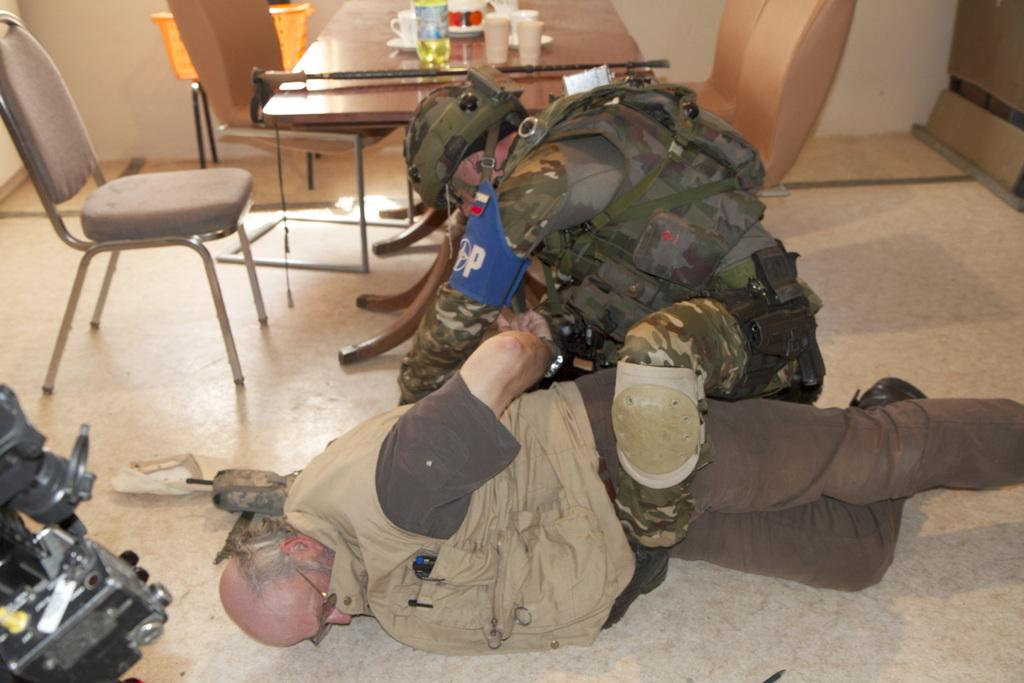How many people are in the image? There are two men in the image. What is the occupation of one of the men? One of the men is an army man. What is the army man doing in the image? The army man is arresting a person. What furniture is present in the image? There is a table and two chairs in the image. What type of transport can be seen in the image? There is no transport visible in the image. What type of order is the army man giving to the person he is arresting? The image does not show the army man giving any orders; it only shows him arresting a person. 